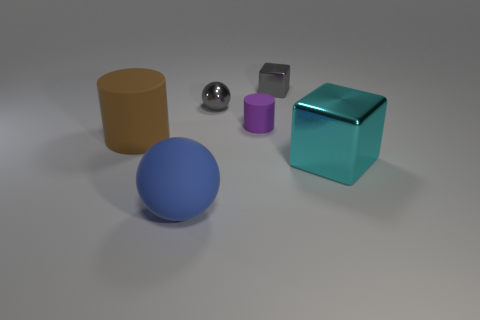What shape is the tiny metal thing that is the same color as the tiny shiny block?
Your answer should be compact. Sphere. Is the blue matte sphere the same size as the gray block?
Offer a terse response. No. What number of objects are either cylinders on the right side of the large blue thing or tiny gray shiny objects behind the gray ball?
Your response must be concise. 2. The small block that is behind the matte cylinder that is on the right side of the blue sphere is made of what material?
Make the answer very short. Metal. What number of other things are there of the same material as the blue sphere
Provide a succinct answer. 2. Is the shape of the brown thing the same as the cyan thing?
Make the answer very short. No. How big is the block right of the small metallic cube?
Make the answer very short. Large. Do the rubber sphere and the metal cube that is left of the cyan thing have the same size?
Provide a short and direct response. No. Are there fewer small purple objects to the left of the tiny purple matte thing than cyan rubber balls?
Give a very brief answer. No. What is the material of the other thing that is the same shape as the large blue matte thing?
Keep it short and to the point. Metal. 